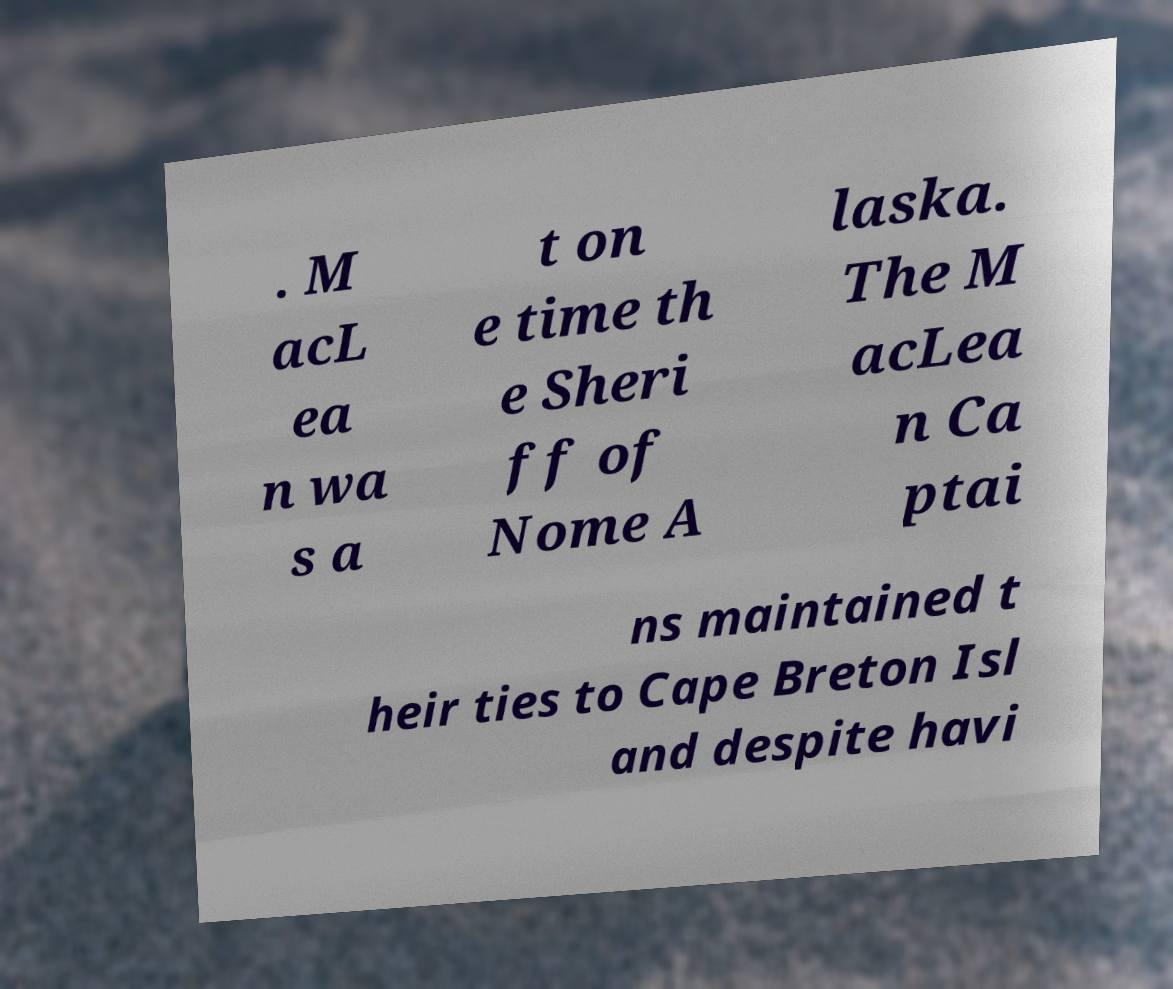What messages or text are displayed in this image? I need them in a readable, typed format. . M acL ea n wa s a t on e time th e Sheri ff of Nome A laska. The M acLea n Ca ptai ns maintained t heir ties to Cape Breton Isl and despite havi 